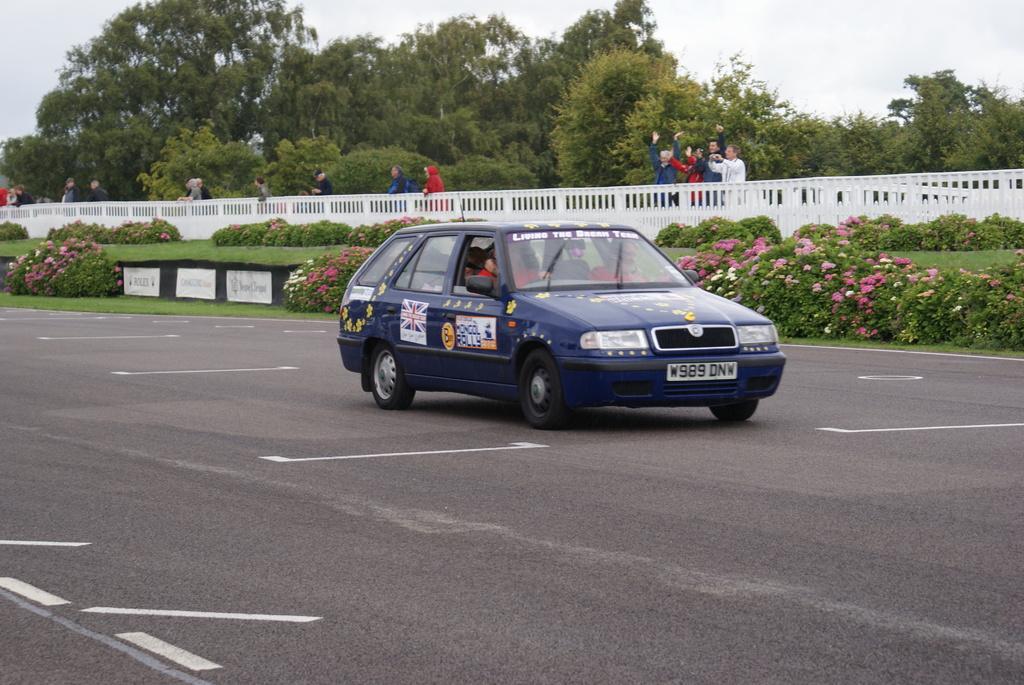Describe this image in one or two sentences. In this image I see a car which is of blue in color and I see few alphabets and numbers on this plate and I see 2 people in it and I see the road on which there are white lines. In the background I see the green grass, bushes on which there are flowers and I see the white wall and I see few people, trees and the sky. 